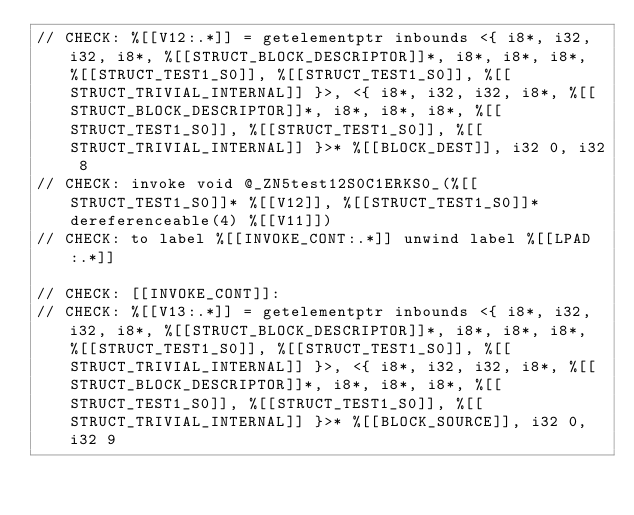Convert code to text. <code><loc_0><loc_0><loc_500><loc_500><_ObjectiveC_>// CHECK: %[[V12:.*]] = getelementptr inbounds <{ i8*, i32, i32, i8*, %[[STRUCT_BLOCK_DESCRIPTOR]]*, i8*, i8*, i8*, %[[STRUCT_TEST1_S0]], %[[STRUCT_TEST1_S0]], %[[STRUCT_TRIVIAL_INTERNAL]] }>, <{ i8*, i32, i32, i8*, %[[STRUCT_BLOCK_DESCRIPTOR]]*, i8*, i8*, i8*, %[[STRUCT_TEST1_S0]], %[[STRUCT_TEST1_S0]], %[[STRUCT_TRIVIAL_INTERNAL]] }>* %[[BLOCK_DEST]], i32 0, i32 8
// CHECK: invoke void @_ZN5test12S0C1ERKS0_(%[[STRUCT_TEST1_S0]]* %[[V12]], %[[STRUCT_TEST1_S0]]* dereferenceable(4) %[[V11]])
// CHECK: to label %[[INVOKE_CONT:.*]] unwind label %[[LPAD:.*]]

// CHECK: [[INVOKE_CONT]]:
// CHECK: %[[V13:.*]] = getelementptr inbounds <{ i8*, i32, i32, i8*, %[[STRUCT_BLOCK_DESCRIPTOR]]*, i8*, i8*, i8*, %[[STRUCT_TEST1_S0]], %[[STRUCT_TEST1_S0]], %[[STRUCT_TRIVIAL_INTERNAL]] }>, <{ i8*, i32, i32, i8*, %[[STRUCT_BLOCK_DESCRIPTOR]]*, i8*, i8*, i8*, %[[STRUCT_TEST1_S0]], %[[STRUCT_TEST1_S0]], %[[STRUCT_TRIVIAL_INTERNAL]] }>* %[[BLOCK_SOURCE]], i32 0, i32 9</code> 